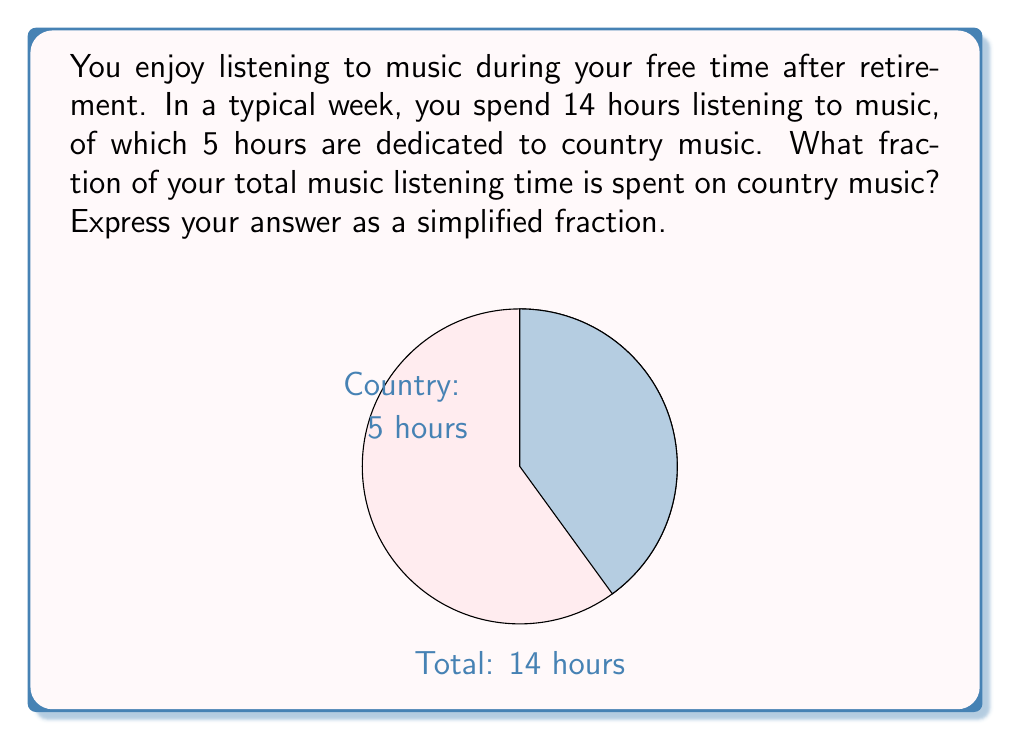Could you help me with this problem? Let's approach this step-by-step:

1) First, we need to identify the important information:
   - Total music listening time per week = 14 hours
   - Time spent listening to country music = 5 hours

2) To find the fraction of time spent on country music, we need to divide the time spent on country music by the total music listening time:

   $$\frac{\text{Time spent on country music}}{\text{Total music listening time}} = \frac{5 \text{ hours}}{14 \text{ hours}}$$

3) This fraction can be simplified by dividing both the numerator and denominator by their greatest common divisor (GCD). The GCD of 5 and 14 is 1, so this fraction is already in its simplest form.

4) Therefore, the fraction of time spent listening to country music is $\frac{5}{14}$.
Answer: $\frac{5}{14}$ 